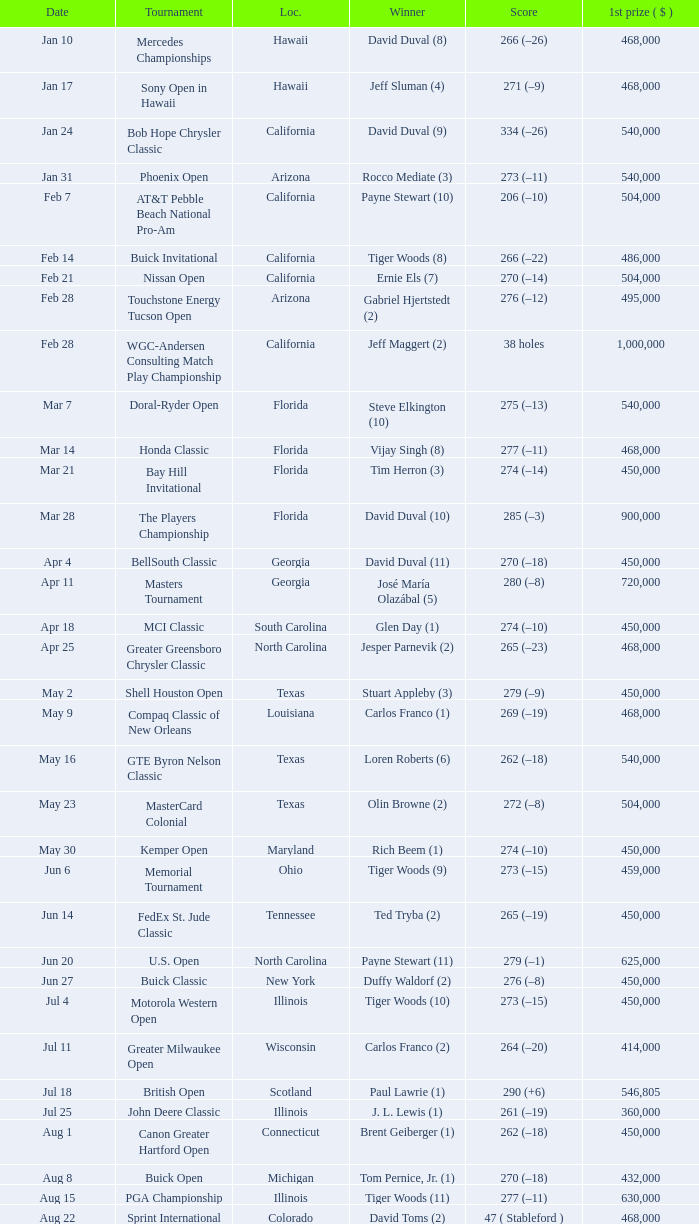Who is the winner of the tournament in Georgia on Oct 3? David Toms (3). 